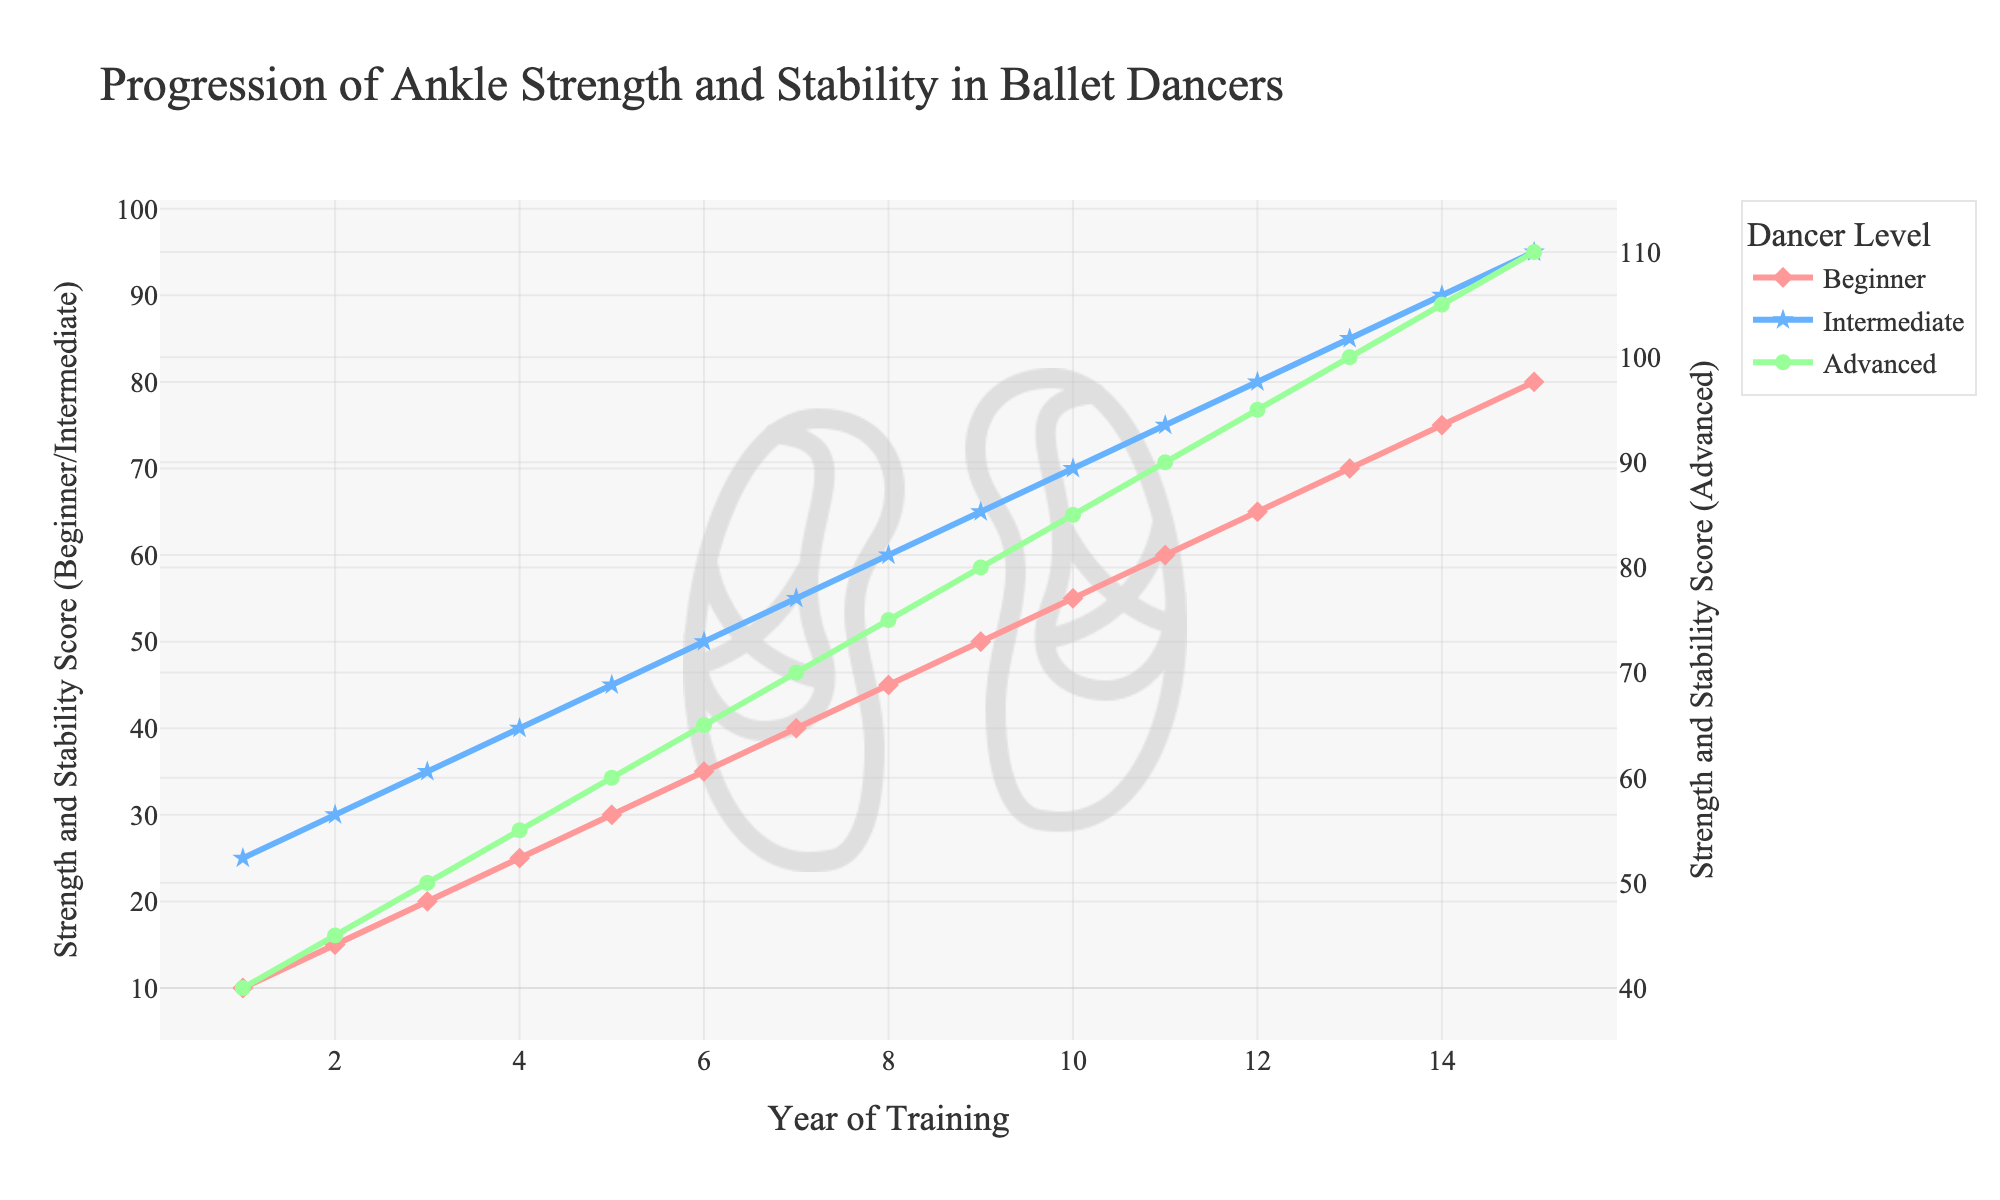Which dancer level shows the most significant improvement in ankle strength and stability over the 15 years? To find the level showing the most significant improvement, subtract the initial value (Year 1) from the final value (Year 15) for each level. Beginner: 80 - 10 = 70, Intermediate: 95 - 25 = 70, Advanced: 110 - 40 = 70. The improvement is the same for all levels.
Answer: Beginner, Intermediate, and Advanced How do the progression lines for the three dancer levels compare visually? Visually, the three lines representing Beginner (red), Intermediate (blue), and Advanced (green) levels show a steady increase over the years. They run parallel to each other, indicating consistent improvement across all levels. Intermediate and Advanced levels are marginally higher in value compared to the Beginner level.
Answer: Steady increase, parallel lines Between Year 5 and Year 10, which dancer level has the highest increase in ankle strength and stability? Calculate the increase by subtracting the value at Year 5 from the value at Year 10 for each level. Beginner: 55 - 30 = 25, Intermediate: 70 - 45 = 25, Advanced: 85 - 60 = 25. All levels have the same increase.
Answer: All levels have the same increase What is the difference in ankle strength and stability scores between the Intermediate and Beginner levels at Year 7? Subtract the Beginner score from the Intermediate score at Year 7. Intermediate: 55, Beginner: 40. Difference: 55 - 40 = 15.
Answer: 15 At which year do all dancer levels first reach a score of at least 50 in ankle strength and stability? Identify the first year when each level reaches at least 50. Beginner: Year 9, Intermediate: Year 5, Advanced: Year 2. The earliest year when all levels meet this criterion is Year 9.
Answer: Year 9 What is the combined score of ankle strength and stability for all dancer levels in Year 8? Add the scores for Beginner, Intermediate, and Advanced levels in Year 8. Beginner: 45, Intermediate: 60, Advanced: 75. Combined score: 45 + 60 + 75 = 180.
Answer: 180 Which year marks the halfway point in the progression timeline and what are the corresponding scores for each level? The timeline has 15 years, so the halfway point is Year 8 (rounding 15/2 to the nearest whole number). Beginner: 45, Intermediate: 60, Advanced: 75.
Answer: Year 8, Beginner: 45, Intermediate: 60, Advanced: 75 